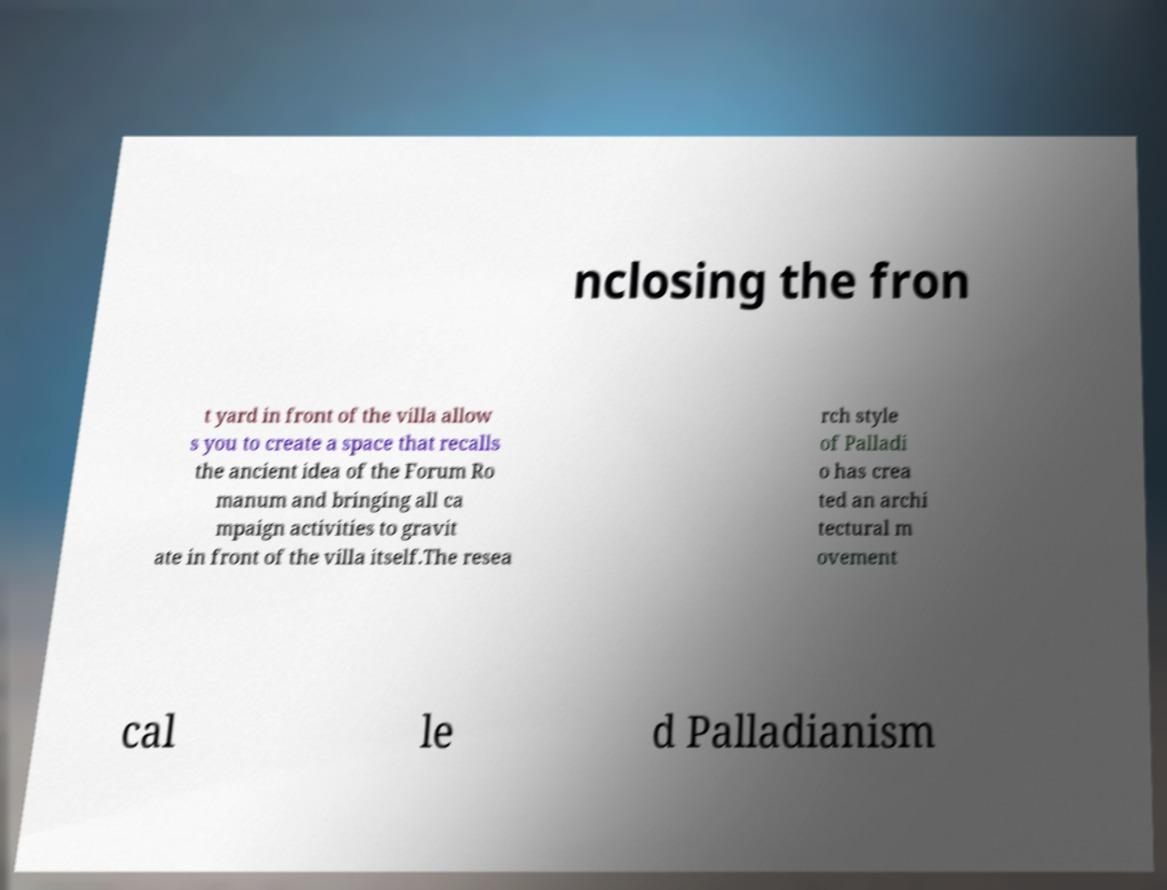I need the written content from this picture converted into text. Can you do that? nclosing the fron t yard in front of the villa allow s you to create a space that recalls the ancient idea of the Forum Ro manum and bringing all ca mpaign activities to gravit ate in front of the villa itself.The resea rch style of Palladi o has crea ted an archi tectural m ovement cal le d Palladianism 